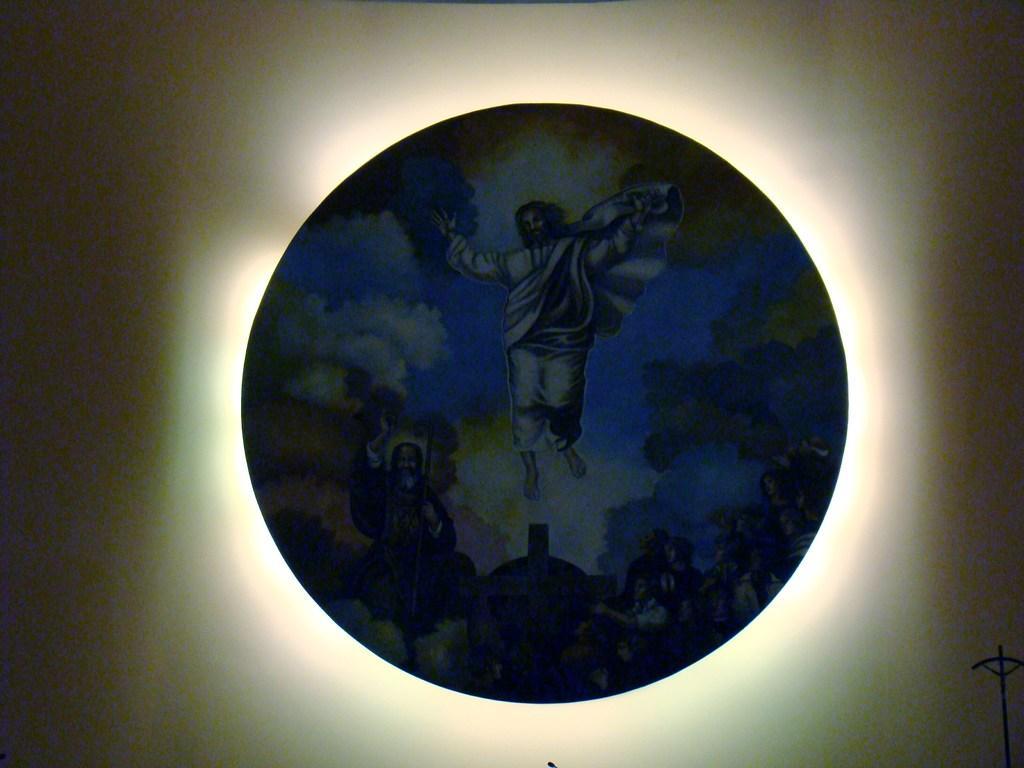Describe this image in one or two sentences. In this image I can see a picture of the Jesus on a round shaped object. 